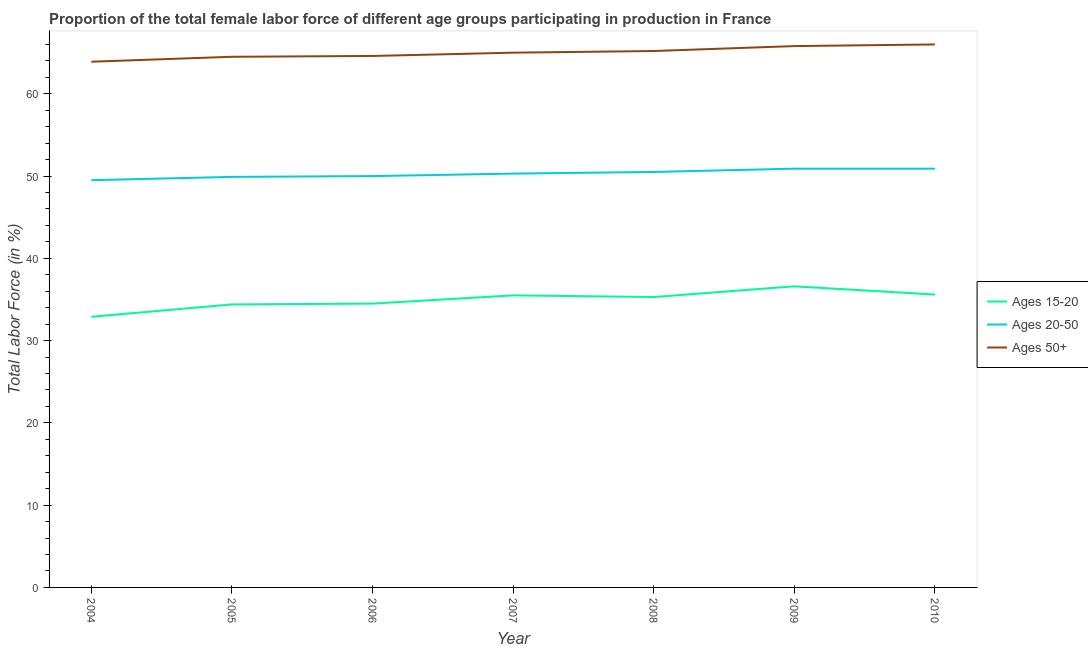What is the percentage of female labor force within the age group 20-50 in 2009?
Provide a succinct answer. 50.9. Across all years, what is the maximum percentage of female labor force within the age group 15-20?
Your answer should be compact. 36.6. Across all years, what is the minimum percentage of female labor force above age 50?
Ensure brevity in your answer.  63.9. What is the total percentage of female labor force above age 50 in the graph?
Offer a very short reply. 455. What is the difference between the percentage of female labor force above age 50 in 2006 and that in 2007?
Give a very brief answer. -0.4. What is the difference between the percentage of female labor force within the age group 15-20 in 2006 and the percentage of female labor force above age 50 in 2004?
Offer a terse response. -29.4. What is the average percentage of female labor force within the age group 20-50 per year?
Give a very brief answer. 50.29. In the year 2007, what is the difference between the percentage of female labor force within the age group 20-50 and percentage of female labor force above age 50?
Make the answer very short. -14.7. In how many years, is the percentage of female labor force within the age group 15-20 greater than 4 %?
Provide a short and direct response. 7. What is the ratio of the percentage of female labor force above age 50 in 2006 to that in 2009?
Offer a very short reply. 0.98. Is the percentage of female labor force within the age group 20-50 in 2004 less than that in 2006?
Give a very brief answer. Yes. What is the difference between the highest and the second highest percentage of female labor force above age 50?
Your answer should be very brief. 0.2. What is the difference between the highest and the lowest percentage of female labor force within the age group 20-50?
Provide a short and direct response. 1.4. In how many years, is the percentage of female labor force within the age group 15-20 greater than the average percentage of female labor force within the age group 15-20 taken over all years?
Your answer should be compact. 4. Is the sum of the percentage of female labor force within the age group 20-50 in 2004 and 2005 greater than the maximum percentage of female labor force above age 50 across all years?
Keep it short and to the point. Yes. Does the percentage of female labor force above age 50 monotonically increase over the years?
Provide a short and direct response. Yes. Is the percentage of female labor force within the age group 20-50 strictly greater than the percentage of female labor force within the age group 15-20 over the years?
Provide a short and direct response. Yes. Is the percentage of female labor force within the age group 20-50 strictly less than the percentage of female labor force above age 50 over the years?
Offer a terse response. Yes. How many years are there in the graph?
Offer a terse response. 7. How many legend labels are there?
Provide a short and direct response. 3. How are the legend labels stacked?
Your answer should be compact. Vertical. What is the title of the graph?
Provide a succinct answer. Proportion of the total female labor force of different age groups participating in production in France. Does "Male employers" appear as one of the legend labels in the graph?
Keep it short and to the point. No. What is the label or title of the X-axis?
Keep it short and to the point. Year. What is the label or title of the Y-axis?
Provide a short and direct response. Total Labor Force (in %). What is the Total Labor Force (in %) of Ages 15-20 in 2004?
Keep it short and to the point. 32.9. What is the Total Labor Force (in %) in Ages 20-50 in 2004?
Make the answer very short. 49.5. What is the Total Labor Force (in %) of Ages 50+ in 2004?
Keep it short and to the point. 63.9. What is the Total Labor Force (in %) in Ages 15-20 in 2005?
Give a very brief answer. 34.4. What is the Total Labor Force (in %) of Ages 20-50 in 2005?
Your answer should be compact. 49.9. What is the Total Labor Force (in %) of Ages 50+ in 2005?
Give a very brief answer. 64.5. What is the Total Labor Force (in %) of Ages 15-20 in 2006?
Provide a succinct answer. 34.5. What is the Total Labor Force (in %) in Ages 20-50 in 2006?
Make the answer very short. 50. What is the Total Labor Force (in %) of Ages 50+ in 2006?
Your response must be concise. 64.6. What is the Total Labor Force (in %) in Ages 15-20 in 2007?
Your answer should be compact. 35.5. What is the Total Labor Force (in %) in Ages 20-50 in 2007?
Offer a very short reply. 50.3. What is the Total Labor Force (in %) in Ages 50+ in 2007?
Ensure brevity in your answer.  65. What is the Total Labor Force (in %) of Ages 15-20 in 2008?
Offer a terse response. 35.3. What is the Total Labor Force (in %) in Ages 20-50 in 2008?
Ensure brevity in your answer.  50.5. What is the Total Labor Force (in %) in Ages 50+ in 2008?
Your answer should be very brief. 65.2. What is the Total Labor Force (in %) of Ages 15-20 in 2009?
Provide a succinct answer. 36.6. What is the Total Labor Force (in %) in Ages 20-50 in 2009?
Offer a terse response. 50.9. What is the Total Labor Force (in %) in Ages 50+ in 2009?
Your answer should be compact. 65.8. What is the Total Labor Force (in %) of Ages 15-20 in 2010?
Your response must be concise. 35.6. What is the Total Labor Force (in %) of Ages 20-50 in 2010?
Your response must be concise. 50.9. What is the Total Labor Force (in %) of Ages 50+ in 2010?
Your answer should be compact. 66. Across all years, what is the maximum Total Labor Force (in %) in Ages 15-20?
Your answer should be very brief. 36.6. Across all years, what is the maximum Total Labor Force (in %) in Ages 20-50?
Ensure brevity in your answer.  50.9. Across all years, what is the minimum Total Labor Force (in %) of Ages 15-20?
Your answer should be compact. 32.9. Across all years, what is the minimum Total Labor Force (in %) of Ages 20-50?
Provide a short and direct response. 49.5. Across all years, what is the minimum Total Labor Force (in %) in Ages 50+?
Keep it short and to the point. 63.9. What is the total Total Labor Force (in %) in Ages 15-20 in the graph?
Your answer should be very brief. 244.8. What is the total Total Labor Force (in %) in Ages 20-50 in the graph?
Give a very brief answer. 352. What is the total Total Labor Force (in %) in Ages 50+ in the graph?
Provide a short and direct response. 455. What is the difference between the Total Labor Force (in %) in Ages 20-50 in 2004 and that in 2005?
Keep it short and to the point. -0.4. What is the difference between the Total Labor Force (in %) in Ages 50+ in 2004 and that in 2005?
Provide a succinct answer. -0.6. What is the difference between the Total Labor Force (in %) in Ages 20-50 in 2004 and that in 2006?
Keep it short and to the point. -0.5. What is the difference between the Total Labor Force (in %) of Ages 50+ in 2004 and that in 2006?
Offer a very short reply. -0.7. What is the difference between the Total Labor Force (in %) in Ages 15-20 in 2004 and that in 2007?
Keep it short and to the point. -2.6. What is the difference between the Total Labor Force (in %) of Ages 20-50 in 2004 and that in 2007?
Provide a short and direct response. -0.8. What is the difference between the Total Labor Force (in %) of Ages 50+ in 2004 and that in 2007?
Keep it short and to the point. -1.1. What is the difference between the Total Labor Force (in %) of Ages 15-20 in 2004 and that in 2008?
Offer a terse response. -2.4. What is the difference between the Total Labor Force (in %) of Ages 50+ in 2004 and that in 2008?
Ensure brevity in your answer.  -1.3. What is the difference between the Total Labor Force (in %) of Ages 20-50 in 2004 and that in 2009?
Provide a short and direct response. -1.4. What is the difference between the Total Labor Force (in %) of Ages 50+ in 2004 and that in 2009?
Keep it short and to the point. -1.9. What is the difference between the Total Labor Force (in %) in Ages 15-20 in 2005 and that in 2006?
Ensure brevity in your answer.  -0.1. What is the difference between the Total Labor Force (in %) in Ages 20-50 in 2005 and that in 2006?
Offer a terse response. -0.1. What is the difference between the Total Labor Force (in %) of Ages 50+ in 2005 and that in 2006?
Your answer should be compact. -0.1. What is the difference between the Total Labor Force (in %) in Ages 20-50 in 2005 and that in 2007?
Give a very brief answer. -0.4. What is the difference between the Total Labor Force (in %) of Ages 50+ in 2005 and that in 2007?
Provide a succinct answer. -0.5. What is the difference between the Total Labor Force (in %) of Ages 20-50 in 2005 and that in 2008?
Offer a terse response. -0.6. What is the difference between the Total Labor Force (in %) in Ages 15-20 in 2005 and that in 2009?
Your answer should be compact. -2.2. What is the difference between the Total Labor Force (in %) of Ages 20-50 in 2005 and that in 2009?
Offer a very short reply. -1. What is the difference between the Total Labor Force (in %) of Ages 50+ in 2005 and that in 2009?
Keep it short and to the point. -1.3. What is the difference between the Total Labor Force (in %) of Ages 15-20 in 2005 and that in 2010?
Offer a very short reply. -1.2. What is the difference between the Total Labor Force (in %) of Ages 50+ in 2005 and that in 2010?
Give a very brief answer. -1.5. What is the difference between the Total Labor Force (in %) in Ages 20-50 in 2006 and that in 2008?
Offer a terse response. -0.5. What is the difference between the Total Labor Force (in %) of Ages 15-20 in 2006 and that in 2010?
Your answer should be very brief. -1.1. What is the difference between the Total Labor Force (in %) in Ages 20-50 in 2006 and that in 2010?
Your answer should be compact. -0.9. What is the difference between the Total Labor Force (in %) in Ages 50+ in 2006 and that in 2010?
Give a very brief answer. -1.4. What is the difference between the Total Labor Force (in %) of Ages 20-50 in 2007 and that in 2008?
Keep it short and to the point. -0.2. What is the difference between the Total Labor Force (in %) in Ages 20-50 in 2007 and that in 2009?
Offer a very short reply. -0.6. What is the difference between the Total Labor Force (in %) in Ages 15-20 in 2008 and that in 2009?
Offer a very short reply. -1.3. What is the difference between the Total Labor Force (in %) of Ages 20-50 in 2008 and that in 2009?
Keep it short and to the point. -0.4. What is the difference between the Total Labor Force (in %) in Ages 50+ in 2008 and that in 2009?
Make the answer very short. -0.6. What is the difference between the Total Labor Force (in %) in Ages 15-20 in 2008 and that in 2010?
Offer a terse response. -0.3. What is the difference between the Total Labor Force (in %) of Ages 20-50 in 2008 and that in 2010?
Offer a terse response. -0.4. What is the difference between the Total Labor Force (in %) of Ages 50+ in 2009 and that in 2010?
Provide a succinct answer. -0.2. What is the difference between the Total Labor Force (in %) in Ages 15-20 in 2004 and the Total Labor Force (in %) in Ages 20-50 in 2005?
Keep it short and to the point. -17. What is the difference between the Total Labor Force (in %) of Ages 15-20 in 2004 and the Total Labor Force (in %) of Ages 50+ in 2005?
Your answer should be compact. -31.6. What is the difference between the Total Labor Force (in %) in Ages 20-50 in 2004 and the Total Labor Force (in %) in Ages 50+ in 2005?
Ensure brevity in your answer.  -15. What is the difference between the Total Labor Force (in %) of Ages 15-20 in 2004 and the Total Labor Force (in %) of Ages 20-50 in 2006?
Offer a terse response. -17.1. What is the difference between the Total Labor Force (in %) of Ages 15-20 in 2004 and the Total Labor Force (in %) of Ages 50+ in 2006?
Give a very brief answer. -31.7. What is the difference between the Total Labor Force (in %) of Ages 20-50 in 2004 and the Total Labor Force (in %) of Ages 50+ in 2006?
Your response must be concise. -15.1. What is the difference between the Total Labor Force (in %) in Ages 15-20 in 2004 and the Total Labor Force (in %) in Ages 20-50 in 2007?
Offer a very short reply. -17.4. What is the difference between the Total Labor Force (in %) of Ages 15-20 in 2004 and the Total Labor Force (in %) of Ages 50+ in 2007?
Keep it short and to the point. -32.1. What is the difference between the Total Labor Force (in %) in Ages 20-50 in 2004 and the Total Labor Force (in %) in Ages 50+ in 2007?
Offer a terse response. -15.5. What is the difference between the Total Labor Force (in %) in Ages 15-20 in 2004 and the Total Labor Force (in %) in Ages 20-50 in 2008?
Your response must be concise. -17.6. What is the difference between the Total Labor Force (in %) of Ages 15-20 in 2004 and the Total Labor Force (in %) of Ages 50+ in 2008?
Offer a very short reply. -32.3. What is the difference between the Total Labor Force (in %) in Ages 20-50 in 2004 and the Total Labor Force (in %) in Ages 50+ in 2008?
Offer a very short reply. -15.7. What is the difference between the Total Labor Force (in %) of Ages 15-20 in 2004 and the Total Labor Force (in %) of Ages 50+ in 2009?
Keep it short and to the point. -32.9. What is the difference between the Total Labor Force (in %) in Ages 20-50 in 2004 and the Total Labor Force (in %) in Ages 50+ in 2009?
Keep it short and to the point. -16.3. What is the difference between the Total Labor Force (in %) in Ages 15-20 in 2004 and the Total Labor Force (in %) in Ages 20-50 in 2010?
Your response must be concise. -18. What is the difference between the Total Labor Force (in %) of Ages 15-20 in 2004 and the Total Labor Force (in %) of Ages 50+ in 2010?
Offer a terse response. -33.1. What is the difference between the Total Labor Force (in %) of Ages 20-50 in 2004 and the Total Labor Force (in %) of Ages 50+ in 2010?
Ensure brevity in your answer.  -16.5. What is the difference between the Total Labor Force (in %) of Ages 15-20 in 2005 and the Total Labor Force (in %) of Ages 20-50 in 2006?
Your response must be concise. -15.6. What is the difference between the Total Labor Force (in %) of Ages 15-20 in 2005 and the Total Labor Force (in %) of Ages 50+ in 2006?
Your response must be concise. -30.2. What is the difference between the Total Labor Force (in %) of Ages 20-50 in 2005 and the Total Labor Force (in %) of Ages 50+ in 2006?
Your answer should be compact. -14.7. What is the difference between the Total Labor Force (in %) in Ages 15-20 in 2005 and the Total Labor Force (in %) in Ages 20-50 in 2007?
Provide a short and direct response. -15.9. What is the difference between the Total Labor Force (in %) in Ages 15-20 in 2005 and the Total Labor Force (in %) in Ages 50+ in 2007?
Provide a short and direct response. -30.6. What is the difference between the Total Labor Force (in %) in Ages 20-50 in 2005 and the Total Labor Force (in %) in Ages 50+ in 2007?
Keep it short and to the point. -15.1. What is the difference between the Total Labor Force (in %) in Ages 15-20 in 2005 and the Total Labor Force (in %) in Ages 20-50 in 2008?
Make the answer very short. -16.1. What is the difference between the Total Labor Force (in %) in Ages 15-20 in 2005 and the Total Labor Force (in %) in Ages 50+ in 2008?
Your response must be concise. -30.8. What is the difference between the Total Labor Force (in %) in Ages 20-50 in 2005 and the Total Labor Force (in %) in Ages 50+ in 2008?
Your response must be concise. -15.3. What is the difference between the Total Labor Force (in %) of Ages 15-20 in 2005 and the Total Labor Force (in %) of Ages 20-50 in 2009?
Provide a succinct answer. -16.5. What is the difference between the Total Labor Force (in %) of Ages 15-20 in 2005 and the Total Labor Force (in %) of Ages 50+ in 2009?
Offer a very short reply. -31.4. What is the difference between the Total Labor Force (in %) in Ages 20-50 in 2005 and the Total Labor Force (in %) in Ages 50+ in 2009?
Provide a short and direct response. -15.9. What is the difference between the Total Labor Force (in %) of Ages 15-20 in 2005 and the Total Labor Force (in %) of Ages 20-50 in 2010?
Provide a succinct answer. -16.5. What is the difference between the Total Labor Force (in %) of Ages 15-20 in 2005 and the Total Labor Force (in %) of Ages 50+ in 2010?
Give a very brief answer. -31.6. What is the difference between the Total Labor Force (in %) of Ages 20-50 in 2005 and the Total Labor Force (in %) of Ages 50+ in 2010?
Provide a succinct answer. -16.1. What is the difference between the Total Labor Force (in %) of Ages 15-20 in 2006 and the Total Labor Force (in %) of Ages 20-50 in 2007?
Ensure brevity in your answer.  -15.8. What is the difference between the Total Labor Force (in %) in Ages 15-20 in 2006 and the Total Labor Force (in %) in Ages 50+ in 2007?
Offer a terse response. -30.5. What is the difference between the Total Labor Force (in %) of Ages 15-20 in 2006 and the Total Labor Force (in %) of Ages 50+ in 2008?
Ensure brevity in your answer.  -30.7. What is the difference between the Total Labor Force (in %) of Ages 20-50 in 2006 and the Total Labor Force (in %) of Ages 50+ in 2008?
Keep it short and to the point. -15.2. What is the difference between the Total Labor Force (in %) in Ages 15-20 in 2006 and the Total Labor Force (in %) in Ages 20-50 in 2009?
Your answer should be compact. -16.4. What is the difference between the Total Labor Force (in %) of Ages 15-20 in 2006 and the Total Labor Force (in %) of Ages 50+ in 2009?
Offer a very short reply. -31.3. What is the difference between the Total Labor Force (in %) of Ages 20-50 in 2006 and the Total Labor Force (in %) of Ages 50+ in 2009?
Offer a terse response. -15.8. What is the difference between the Total Labor Force (in %) in Ages 15-20 in 2006 and the Total Labor Force (in %) in Ages 20-50 in 2010?
Ensure brevity in your answer.  -16.4. What is the difference between the Total Labor Force (in %) of Ages 15-20 in 2006 and the Total Labor Force (in %) of Ages 50+ in 2010?
Your answer should be compact. -31.5. What is the difference between the Total Labor Force (in %) of Ages 20-50 in 2006 and the Total Labor Force (in %) of Ages 50+ in 2010?
Offer a very short reply. -16. What is the difference between the Total Labor Force (in %) of Ages 15-20 in 2007 and the Total Labor Force (in %) of Ages 50+ in 2008?
Ensure brevity in your answer.  -29.7. What is the difference between the Total Labor Force (in %) of Ages 20-50 in 2007 and the Total Labor Force (in %) of Ages 50+ in 2008?
Ensure brevity in your answer.  -14.9. What is the difference between the Total Labor Force (in %) of Ages 15-20 in 2007 and the Total Labor Force (in %) of Ages 20-50 in 2009?
Your answer should be compact. -15.4. What is the difference between the Total Labor Force (in %) of Ages 15-20 in 2007 and the Total Labor Force (in %) of Ages 50+ in 2009?
Give a very brief answer. -30.3. What is the difference between the Total Labor Force (in %) of Ages 20-50 in 2007 and the Total Labor Force (in %) of Ages 50+ in 2009?
Your response must be concise. -15.5. What is the difference between the Total Labor Force (in %) of Ages 15-20 in 2007 and the Total Labor Force (in %) of Ages 20-50 in 2010?
Offer a very short reply. -15.4. What is the difference between the Total Labor Force (in %) in Ages 15-20 in 2007 and the Total Labor Force (in %) in Ages 50+ in 2010?
Your response must be concise. -30.5. What is the difference between the Total Labor Force (in %) of Ages 20-50 in 2007 and the Total Labor Force (in %) of Ages 50+ in 2010?
Offer a terse response. -15.7. What is the difference between the Total Labor Force (in %) of Ages 15-20 in 2008 and the Total Labor Force (in %) of Ages 20-50 in 2009?
Give a very brief answer. -15.6. What is the difference between the Total Labor Force (in %) of Ages 15-20 in 2008 and the Total Labor Force (in %) of Ages 50+ in 2009?
Provide a succinct answer. -30.5. What is the difference between the Total Labor Force (in %) in Ages 20-50 in 2008 and the Total Labor Force (in %) in Ages 50+ in 2009?
Offer a very short reply. -15.3. What is the difference between the Total Labor Force (in %) of Ages 15-20 in 2008 and the Total Labor Force (in %) of Ages 20-50 in 2010?
Your response must be concise. -15.6. What is the difference between the Total Labor Force (in %) of Ages 15-20 in 2008 and the Total Labor Force (in %) of Ages 50+ in 2010?
Offer a terse response. -30.7. What is the difference between the Total Labor Force (in %) in Ages 20-50 in 2008 and the Total Labor Force (in %) in Ages 50+ in 2010?
Your answer should be compact. -15.5. What is the difference between the Total Labor Force (in %) of Ages 15-20 in 2009 and the Total Labor Force (in %) of Ages 20-50 in 2010?
Your answer should be very brief. -14.3. What is the difference between the Total Labor Force (in %) in Ages 15-20 in 2009 and the Total Labor Force (in %) in Ages 50+ in 2010?
Make the answer very short. -29.4. What is the difference between the Total Labor Force (in %) of Ages 20-50 in 2009 and the Total Labor Force (in %) of Ages 50+ in 2010?
Your answer should be compact. -15.1. What is the average Total Labor Force (in %) in Ages 15-20 per year?
Make the answer very short. 34.97. What is the average Total Labor Force (in %) in Ages 20-50 per year?
Give a very brief answer. 50.29. What is the average Total Labor Force (in %) of Ages 50+ per year?
Offer a terse response. 65. In the year 2004, what is the difference between the Total Labor Force (in %) in Ages 15-20 and Total Labor Force (in %) in Ages 20-50?
Ensure brevity in your answer.  -16.6. In the year 2004, what is the difference between the Total Labor Force (in %) of Ages 15-20 and Total Labor Force (in %) of Ages 50+?
Make the answer very short. -31. In the year 2004, what is the difference between the Total Labor Force (in %) in Ages 20-50 and Total Labor Force (in %) in Ages 50+?
Give a very brief answer. -14.4. In the year 2005, what is the difference between the Total Labor Force (in %) in Ages 15-20 and Total Labor Force (in %) in Ages 20-50?
Offer a terse response. -15.5. In the year 2005, what is the difference between the Total Labor Force (in %) in Ages 15-20 and Total Labor Force (in %) in Ages 50+?
Your answer should be very brief. -30.1. In the year 2005, what is the difference between the Total Labor Force (in %) of Ages 20-50 and Total Labor Force (in %) of Ages 50+?
Provide a short and direct response. -14.6. In the year 2006, what is the difference between the Total Labor Force (in %) in Ages 15-20 and Total Labor Force (in %) in Ages 20-50?
Ensure brevity in your answer.  -15.5. In the year 2006, what is the difference between the Total Labor Force (in %) in Ages 15-20 and Total Labor Force (in %) in Ages 50+?
Your answer should be very brief. -30.1. In the year 2006, what is the difference between the Total Labor Force (in %) in Ages 20-50 and Total Labor Force (in %) in Ages 50+?
Make the answer very short. -14.6. In the year 2007, what is the difference between the Total Labor Force (in %) of Ages 15-20 and Total Labor Force (in %) of Ages 20-50?
Provide a succinct answer. -14.8. In the year 2007, what is the difference between the Total Labor Force (in %) in Ages 15-20 and Total Labor Force (in %) in Ages 50+?
Offer a terse response. -29.5. In the year 2007, what is the difference between the Total Labor Force (in %) in Ages 20-50 and Total Labor Force (in %) in Ages 50+?
Offer a very short reply. -14.7. In the year 2008, what is the difference between the Total Labor Force (in %) of Ages 15-20 and Total Labor Force (in %) of Ages 20-50?
Offer a terse response. -15.2. In the year 2008, what is the difference between the Total Labor Force (in %) in Ages 15-20 and Total Labor Force (in %) in Ages 50+?
Your answer should be very brief. -29.9. In the year 2008, what is the difference between the Total Labor Force (in %) of Ages 20-50 and Total Labor Force (in %) of Ages 50+?
Your answer should be compact. -14.7. In the year 2009, what is the difference between the Total Labor Force (in %) in Ages 15-20 and Total Labor Force (in %) in Ages 20-50?
Provide a succinct answer. -14.3. In the year 2009, what is the difference between the Total Labor Force (in %) of Ages 15-20 and Total Labor Force (in %) of Ages 50+?
Offer a terse response. -29.2. In the year 2009, what is the difference between the Total Labor Force (in %) of Ages 20-50 and Total Labor Force (in %) of Ages 50+?
Make the answer very short. -14.9. In the year 2010, what is the difference between the Total Labor Force (in %) in Ages 15-20 and Total Labor Force (in %) in Ages 20-50?
Keep it short and to the point. -15.3. In the year 2010, what is the difference between the Total Labor Force (in %) of Ages 15-20 and Total Labor Force (in %) of Ages 50+?
Give a very brief answer. -30.4. In the year 2010, what is the difference between the Total Labor Force (in %) of Ages 20-50 and Total Labor Force (in %) of Ages 50+?
Ensure brevity in your answer.  -15.1. What is the ratio of the Total Labor Force (in %) in Ages 15-20 in 2004 to that in 2005?
Provide a succinct answer. 0.96. What is the ratio of the Total Labor Force (in %) in Ages 15-20 in 2004 to that in 2006?
Provide a short and direct response. 0.95. What is the ratio of the Total Labor Force (in %) in Ages 20-50 in 2004 to that in 2006?
Your answer should be compact. 0.99. What is the ratio of the Total Labor Force (in %) of Ages 50+ in 2004 to that in 2006?
Ensure brevity in your answer.  0.99. What is the ratio of the Total Labor Force (in %) of Ages 15-20 in 2004 to that in 2007?
Offer a terse response. 0.93. What is the ratio of the Total Labor Force (in %) of Ages 20-50 in 2004 to that in 2007?
Keep it short and to the point. 0.98. What is the ratio of the Total Labor Force (in %) of Ages 50+ in 2004 to that in 2007?
Offer a terse response. 0.98. What is the ratio of the Total Labor Force (in %) in Ages 15-20 in 2004 to that in 2008?
Provide a succinct answer. 0.93. What is the ratio of the Total Labor Force (in %) in Ages 20-50 in 2004 to that in 2008?
Provide a short and direct response. 0.98. What is the ratio of the Total Labor Force (in %) of Ages 50+ in 2004 to that in 2008?
Provide a succinct answer. 0.98. What is the ratio of the Total Labor Force (in %) in Ages 15-20 in 2004 to that in 2009?
Give a very brief answer. 0.9. What is the ratio of the Total Labor Force (in %) of Ages 20-50 in 2004 to that in 2009?
Provide a succinct answer. 0.97. What is the ratio of the Total Labor Force (in %) in Ages 50+ in 2004 to that in 2009?
Give a very brief answer. 0.97. What is the ratio of the Total Labor Force (in %) in Ages 15-20 in 2004 to that in 2010?
Make the answer very short. 0.92. What is the ratio of the Total Labor Force (in %) in Ages 20-50 in 2004 to that in 2010?
Provide a short and direct response. 0.97. What is the ratio of the Total Labor Force (in %) of Ages 50+ in 2004 to that in 2010?
Provide a short and direct response. 0.97. What is the ratio of the Total Labor Force (in %) in Ages 15-20 in 2005 to that in 2006?
Your response must be concise. 1. What is the ratio of the Total Labor Force (in %) in Ages 50+ in 2005 to that in 2006?
Provide a succinct answer. 1. What is the ratio of the Total Labor Force (in %) in Ages 20-50 in 2005 to that in 2007?
Offer a terse response. 0.99. What is the ratio of the Total Labor Force (in %) of Ages 50+ in 2005 to that in 2007?
Your answer should be compact. 0.99. What is the ratio of the Total Labor Force (in %) of Ages 15-20 in 2005 to that in 2008?
Your answer should be compact. 0.97. What is the ratio of the Total Labor Force (in %) of Ages 20-50 in 2005 to that in 2008?
Give a very brief answer. 0.99. What is the ratio of the Total Labor Force (in %) in Ages 50+ in 2005 to that in 2008?
Your answer should be very brief. 0.99. What is the ratio of the Total Labor Force (in %) of Ages 15-20 in 2005 to that in 2009?
Provide a short and direct response. 0.94. What is the ratio of the Total Labor Force (in %) of Ages 20-50 in 2005 to that in 2009?
Offer a very short reply. 0.98. What is the ratio of the Total Labor Force (in %) in Ages 50+ in 2005 to that in 2009?
Ensure brevity in your answer.  0.98. What is the ratio of the Total Labor Force (in %) in Ages 15-20 in 2005 to that in 2010?
Provide a succinct answer. 0.97. What is the ratio of the Total Labor Force (in %) of Ages 20-50 in 2005 to that in 2010?
Your response must be concise. 0.98. What is the ratio of the Total Labor Force (in %) of Ages 50+ in 2005 to that in 2010?
Provide a succinct answer. 0.98. What is the ratio of the Total Labor Force (in %) of Ages 15-20 in 2006 to that in 2007?
Provide a short and direct response. 0.97. What is the ratio of the Total Labor Force (in %) of Ages 15-20 in 2006 to that in 2008?
Keep it short and to the point. 0.98. What is the ratio of the Total Labor Force (in %) of Ages 15-20 in 2006 to that in 2009?
Your answer should be very brief. 0.94. What is the ratio of the Total Labor Force (in %) of Ages 20-50 in 2006 to that in 2009?
Offer a terse response. 0.98. What is the ratio of the Total Labor Force (in %) in Ages 50+ in 2006 to that in 2009?
Your response must be concise. 0.98. What is the ratio of the Total Labor Force (in %) in Ages 15-20 in 2006 to that in 2010?
Offer a terse response. 0.97. What is the ratio of the Total Labor Force (in %) in Ages 20-50 in 2006 to that in 2010?
Your answer should be very brief. 0.98. What is the ratio of the Total Labor Force (in %) in Ages 50+ in 2006 to that in 2010?
Keep it short and to the point. 0.98. What is the ratio of the Total Labor Force (in %) of Ages 50+ in 2007 to that in 2008?
Your answer should be compact. 1. What is the ratio of the Total Labor Force (in %) of Ages 15-20 in 2007 to that in 2009?
Provide a succinct answer. 0.97. What is the ratio of the Total Labor Force (in %) of Ages 15-20 in 2007 to that in 2010?
Provide a succinct answer. 1. What is the ratio of the Total Labor Force (in %) in Ages 20-50 in 2007 to that in 2010?
Your answer should be very brief. 0.99. What is the ratio of the Total Labor Force (in %) of Ages 50+ in 2007 to that in 2010?
Provide a short and direct response. 0.98. What is the ratio of the Total Labor Force (in %) in Ages 15-20 in 2008 to that in 2009?
Provide a short and direct response. 0.96. What is the ratio of the Total Labor Force (in %) in Ages 20-50 in 2008 to that in 2009?
Keep it short and to the point. 0.99. What is the ratio of the Total Labor Force (in %) in Ages 50+ in 2008 to that in 2009?
Make the answer very short. 0.99. What is the ratio of the Total Labor Force (in %) of Ages 50+ in 2008 to that in 2010?
Ensure brevity in your answer.  0.99. What is the ratio of the Total Labor Force (in %) of Ages 15-20 in 2009 to that in 2010?
Provide a succinct answer. 1.03. What is the ratio of the Total Labor Force (in %) of Ages 20-50 in 2009 to that in 2010?
Offer a terse response. 1. What is the ratio of the Total Labor Force (in %) of Ages 50+ in 2009 to that in 2010?
Give a very brief answer. 1. What is the difference between the highest and the second highest Total Labor Force (in %) in Ages 50+?
Provide a short and direct response. 0.2. What is the difference between the highest and the lowest Total Labor Force (in %) of Ages 15-20?
Ensure brevity in your answer.  3.7. 